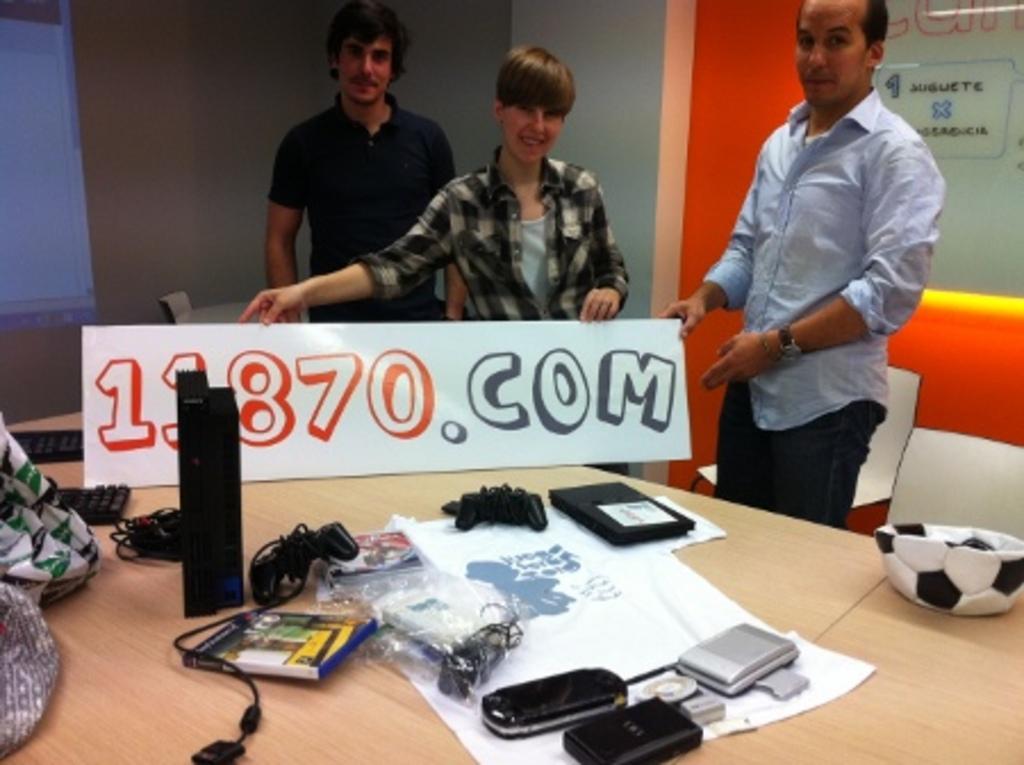How would you summarize this image in a sentence or two? In this picture there are three persons standing behind the table. There are books, wires, devices, ball, bag, keyboards on the table. At the back there is a screen. 